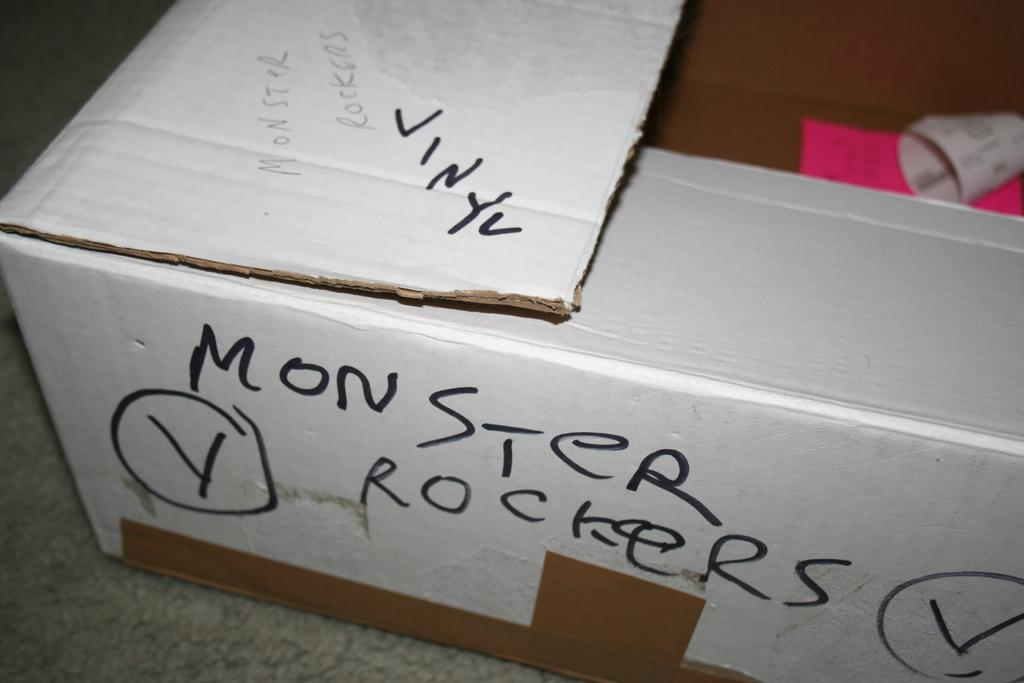<image>
Summarize the visual content of the image. A white cardboard box labelled "Monster Rockers Vinyl" sits on a carpeted floor. 